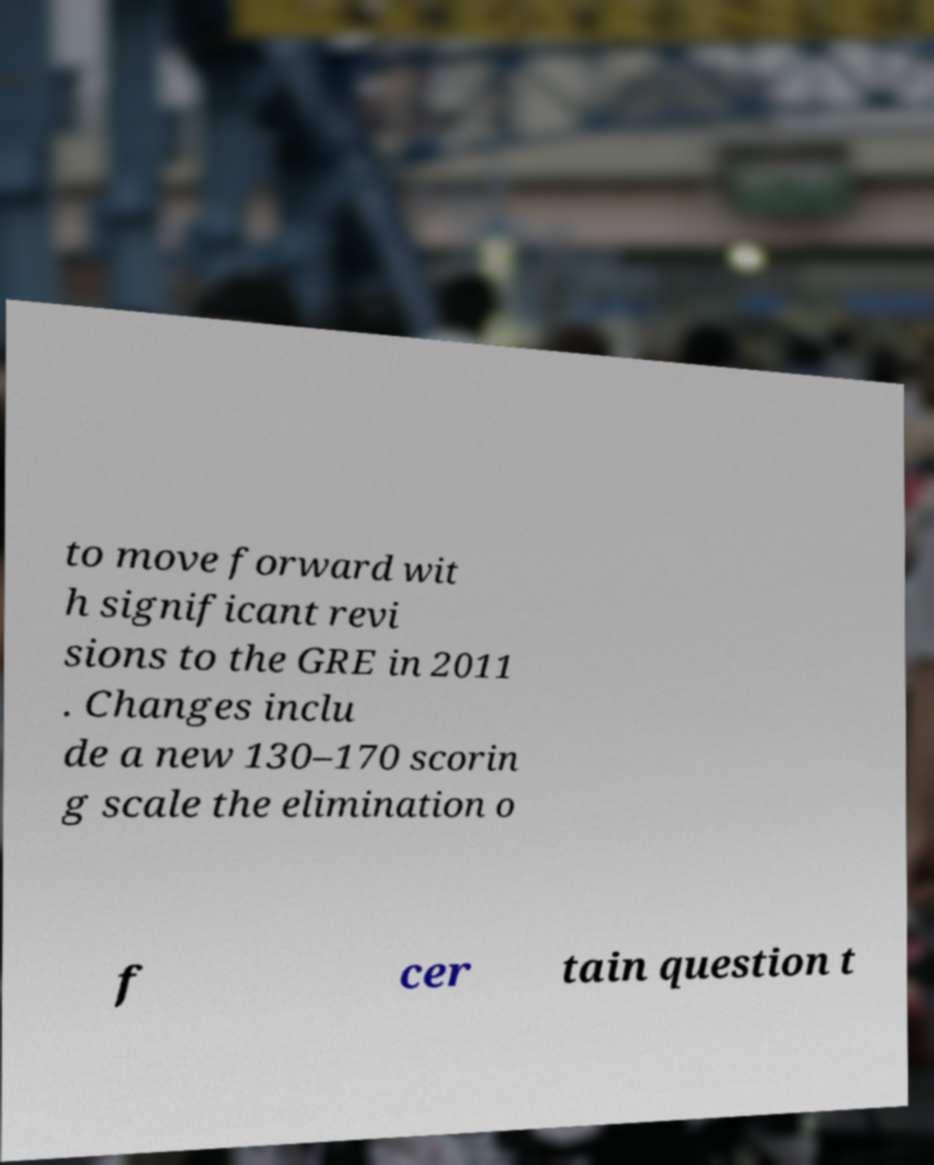For documentation purposes, I need the text within this image transcribed. Could you provide that? to move forward wit h significant revi sions to the GRE in 2011 . Changes inclu de a new 130–170 scorin g scale the elimination o f cer tain question t 